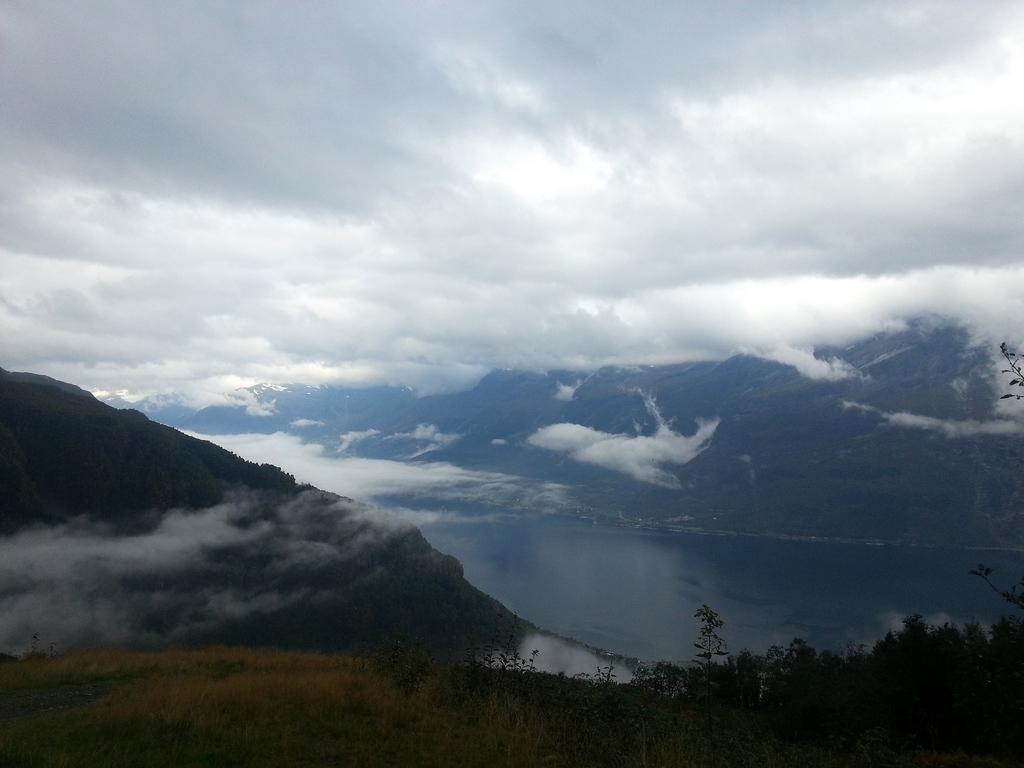Please provide a concise description of this image. In this image there is the sky, there are clouds in the sky, there is a river truncated towards the right of the image, there is a mountain truncated towards the left of the image, there are plants truncated towards the bottom of the image. 